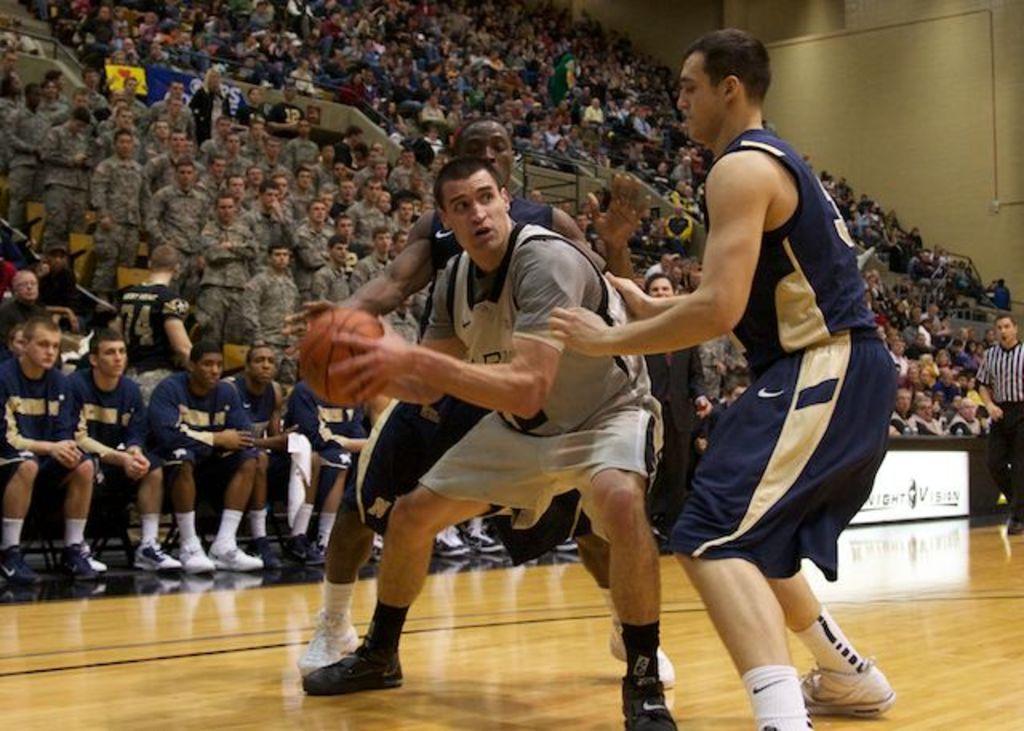In one or two sentences, can you explain what this image depicts? In this picture we can see three persons are playing basketball game, in the background there are some people sitting and some people are standing, on the right side there is a wall, a man in the middle is holding a ball. 